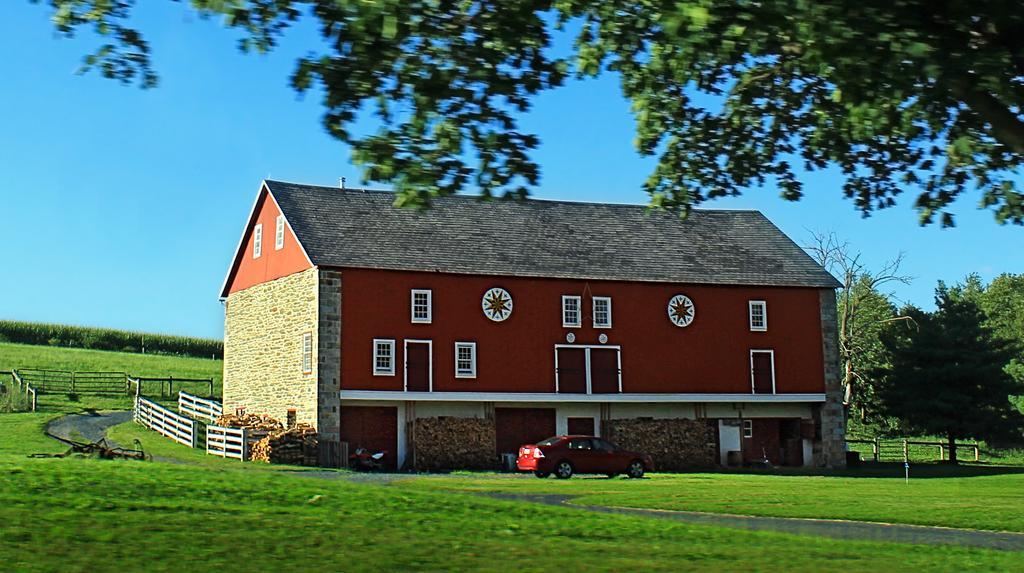Could you give a brief overview of what you see in this image? In the center of the image there is a house. There is a car. At the bottom of the image there is grass. There is a road. There is a fencing. At the top of the image there is sky. There is a tree. In the background of the image there are trees. 